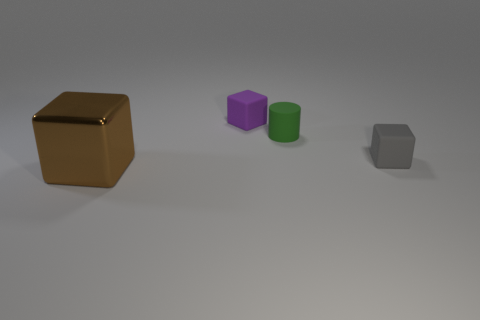Subtract all brown shiny blocks. How many blocks are left? 2 Subtract all gray cubes. How many cubes are left? 2 Subtract all cubes. How many objects are left? 1 Add 2 brown metal cubes. How many objects exist? 6 Subtract 1 green cylinders. How many objects are left? 3 Subtract 1 cylinders. How many cylinders are left? 0 Subtract all gray cylinders. Subtract all gray spheres. How many cylinders are left? 1 Subtract all brown balls. How many green blocks are left? 0 Subtract all big blue balls. Subtract all matte things. How many objects are left? 1 Add 2 brown shiny things. How many brown shiny things are left? 3 